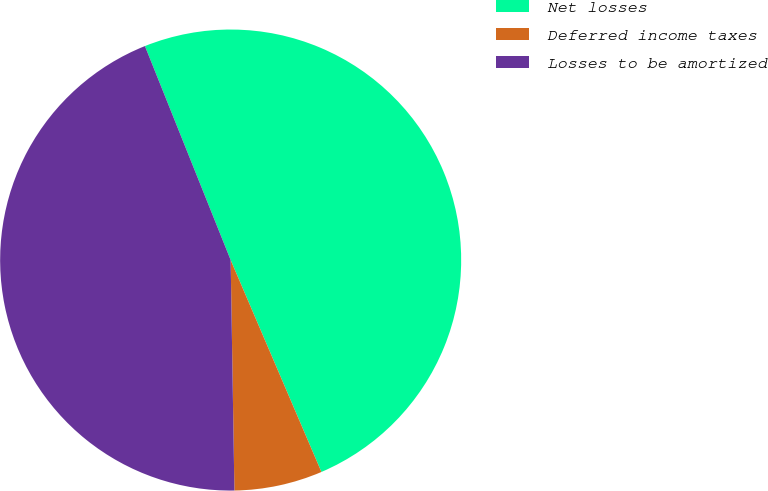Convert chart. <chart><loc_0><loc_0><loc_500><loc_500><pie_chart><fcel>Net losses<fcel>Deferred income taxes<fcel>Losses to be amortized<nl><fcel>49.62%<fcel>6.18%<fcel>44.19%<nl></chart> 